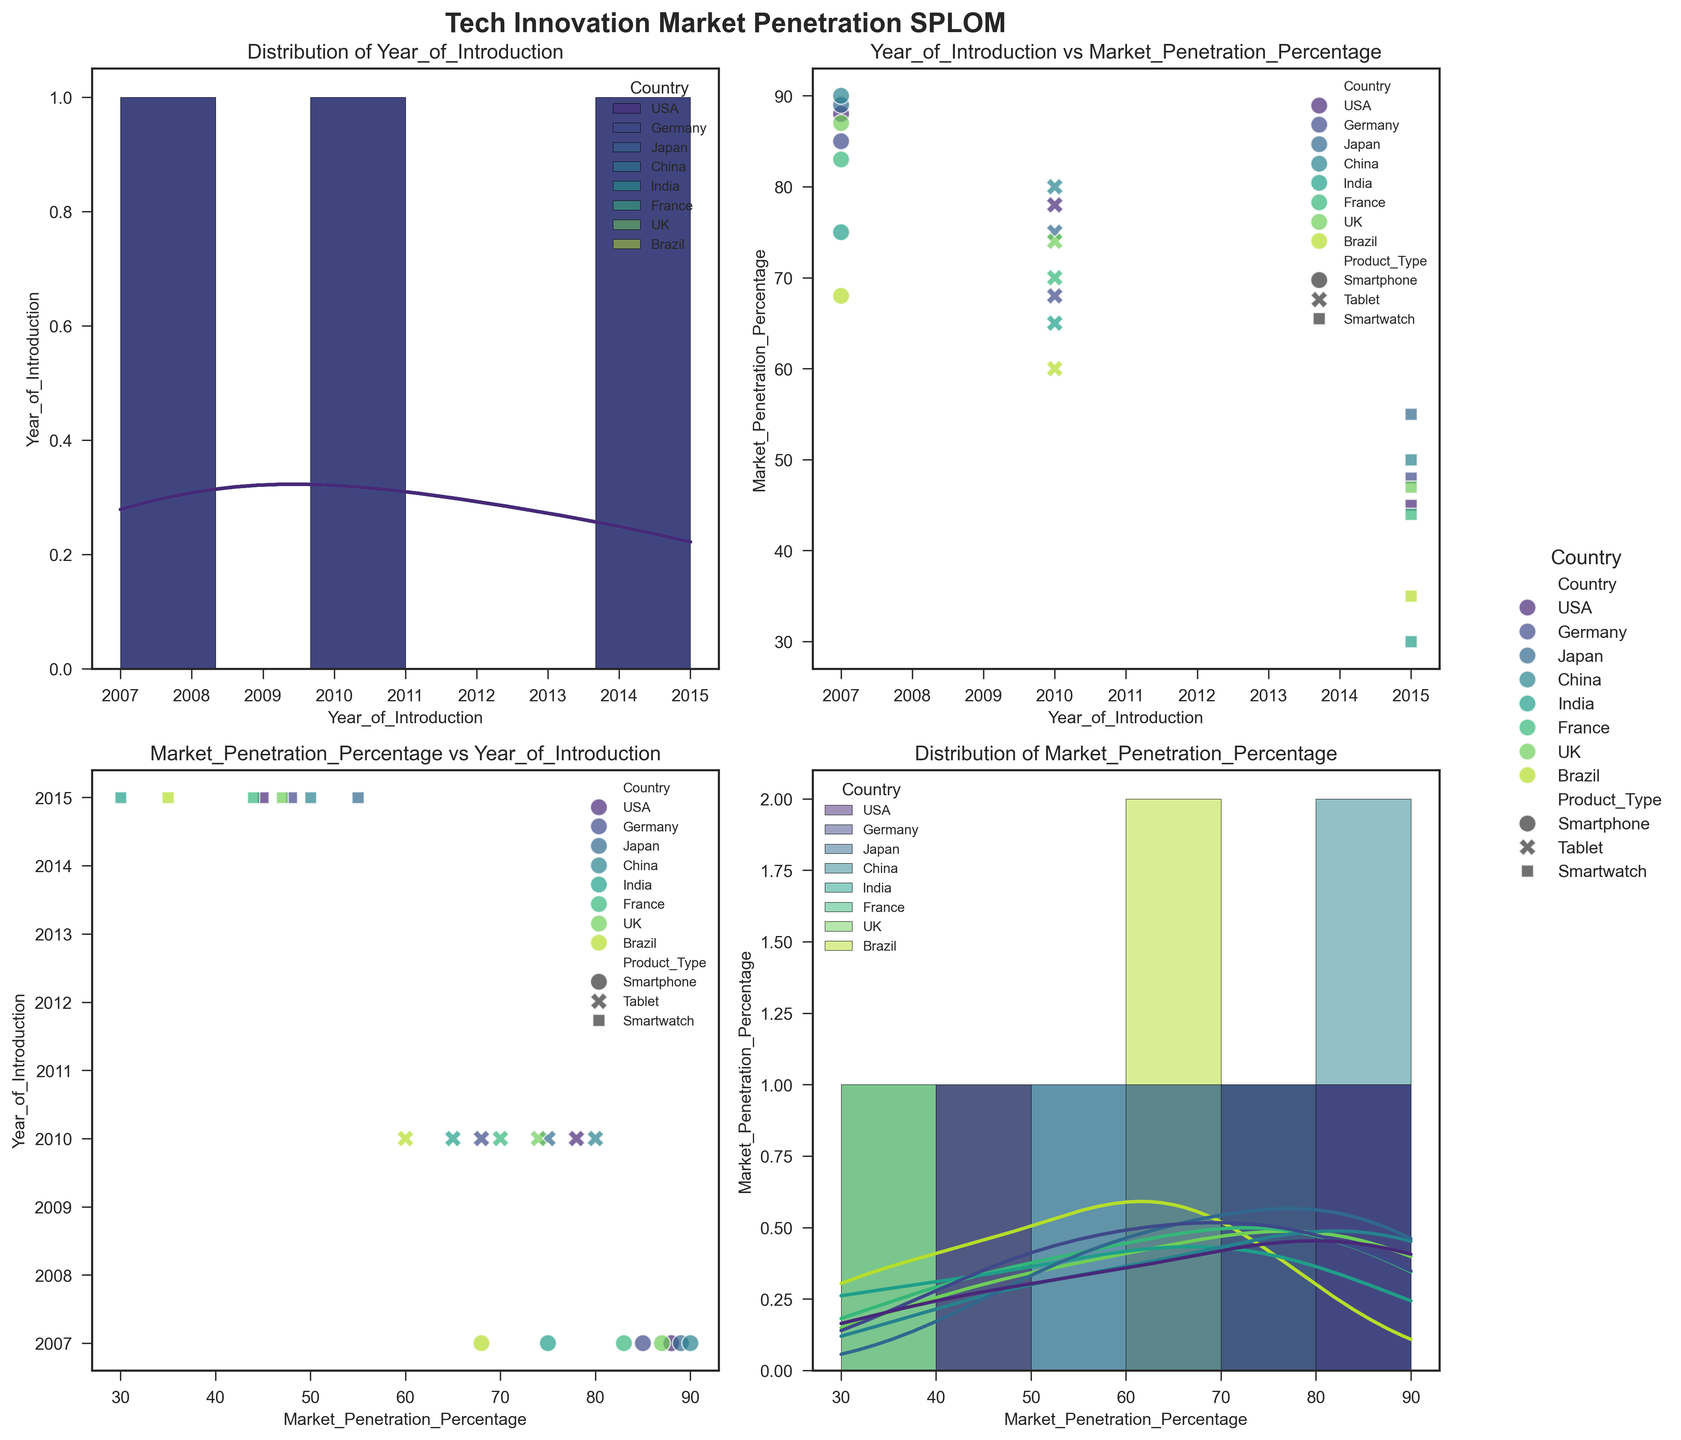What is the title of the figure? The title of the figure is displayed at the top, prominently in bold.
Answer: Tech Innovation Market Penetration SPLOM How many data variables are plotted in each scatter plot? By looking at each scatter plot, you can see that two variables are compared on the X and Y axes.
Answer: 2 Which country has the highest market penetration percentage for smartphones introduced in 2007? In the scatter plot comparing Year_of_Introduction and Market_Penetration_Percentage, points marked for smartphones introduced in 2007 indicate that China has the highest market penetration percentage.
Answer: China What is the general trend in market penetration percentages for smartwatches from 2015 across all countries? By observing the scatter plots involving smartwatches from 2015, you can note the trend that the market penetration percentage is generally lower compared to smartphones and tablets, with most points falling below 55%.
Answer: Lower market penetration What is the relationship between Year_of_Introduction and Market_Penetration_Percentage across different product types? Scatter plots of different product types against Year_of_Introduction show varying degrees of market penetration with smartphones consistently high, tablets moderately high, and smartwatches lower overall.
Answer: Varies: High for smartphones, moderate for tablets, low for smartwatches Which country has the lowest median market penetration percentage for tablets introduced in 2010? Observing the scatter plot for Year_of_Introduction vs. Market_Penetration_Percentage for tablets from 2010, you'll see the distribution and median points, identifying that Brazil has the lowest median penetration rate.
Answer: Brazil For each product type, which country shows the greatest variance in market penetration percentage? By comparing the spread of points for each country across all product types in the scatter plots, you can observe that the greatest disparity is typically seen in countries like India and Brazil, especially for smartwatches.
Answer: India and Brazil for smartwatches Is there any country where the market penetration percentage for all product types falls within the same small range? By looking at scatter plots for any country and checking the range of Market_Penetration_Percentage values for each type, you see that Japan has closely grouped penetration rates for all product types.
Answer: Japan Which country’s smartphones have the closest market penetration percentage to the UK’s tablets? Referring to the scatter plot, you can compare the market penetration percentages of smartphones in different countries and tablets in the UK. USA smartphones show similar values to UK tablets.
Answer: USA What is the most visible trend in the market penetration percentage from 2007 to 2015 across all countries? Observing the scatter plots over the years, you see a visible trend where newer product types like smartwatches have lower penetration compared to older types like smartphones and tablets.
Answer: Newer products have lower penetration 